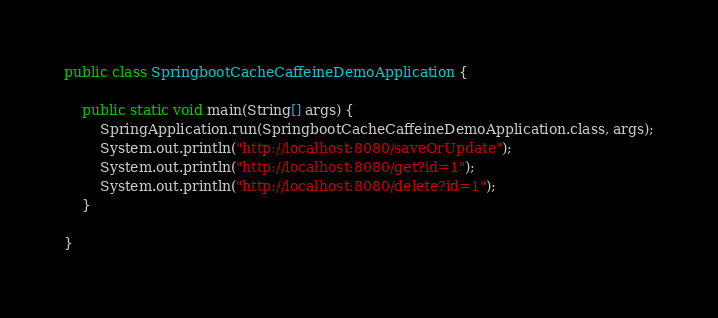Convert code to text. <code><loc_0><loc_0><loc_500><loc_500><_Java_>public class SpringbootCacheCaffeineDemoApplication {

    public static void main(String[] args) {
        SpringApplication.run(SpringbootCacheCaffeineDemoApplication.class, args);
        System.out.println("http://localhost:8080/saveOrUpdate");
        System.out.println("http://localhost:8080/get?id=1");
        System.out.println("http://localhost:8080/delete?id=1");
    }

}
</code> 